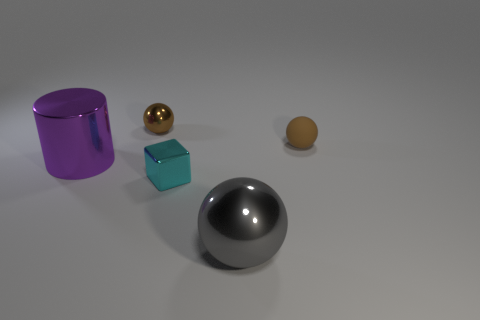How many spheres are behind the big metal object to the right of the shiny cube?
Keep it short and to the point. 2. What shape is the tiny thing on the right side of the metal sphere that is on the right side of the small shiny thing that is to the left of the cyan cube?
Offer a terse response. Sphere. What size is the gray object?
Ensure brevity in your answer.  Large. Is there a cyan object made of the same material as the gray sphere?
Keep it short and to the point. Yes. There is a gray metallic object that is the same shape as the tiny brown shiny object; what is its size?
Your response must be concise. Large. Is the number of brown spheres that are left of the tiny metallic block the same as the number of brown rubber things?
Provide a succinct answer. Yes. There is a small matte thing that is on the right side of the purple object; is it the same shape as the purple metal thing?
Give a very brief answer. No. What is the shape of the cyan object?
Ensure brevity in your answer.  Cube. What is the material of the brown object in front of the metal ball that is behind the large metallic thing to the left of the cyan shiny cube?
Provide a succinct answer. Rubber. There is a thing that is the same color as the rubber ball; what is its material?
Your answer should be compact. Metal. 